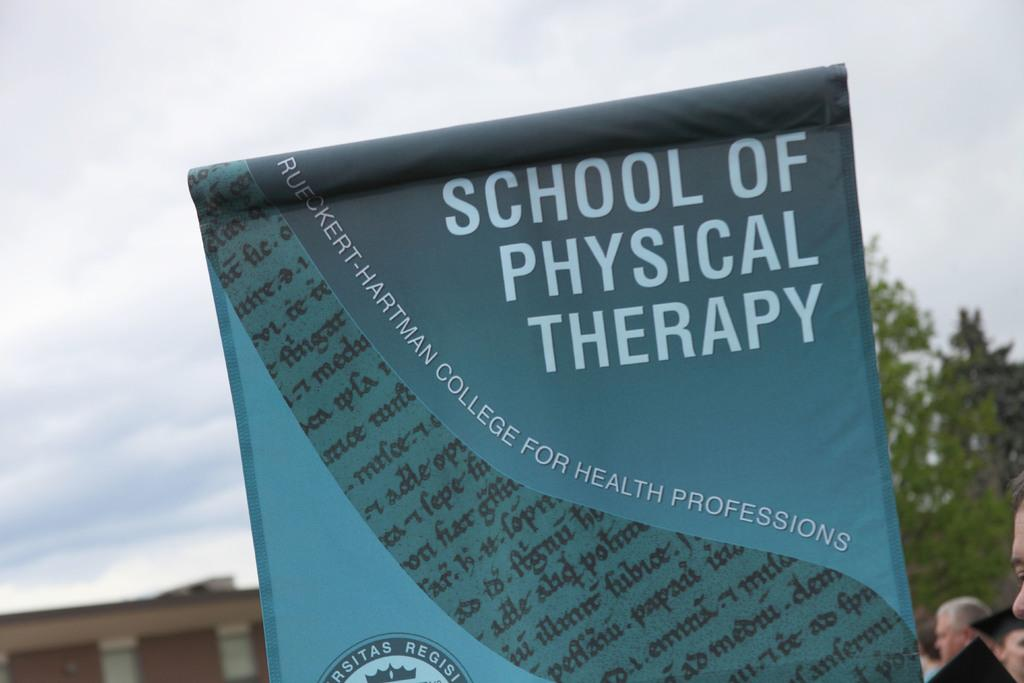What is located in the foreground of the picture? There is a banner in the foreground of the picture. What can be seen on the right side of the picture? There are people and a tree on the right side of the picture. What is on the left side of the picture? There is a building on the left side of the picture. How would you describe the sky in the picture? The sky is cloudy in the picture. What type of shoe can be seen on the tree in the image? There is no shoe present on the tree in the image; it only features people and a tree. What route are the people taking in the image? The image does not provide information about the route the people are taking; it only shows them standing near a tree. 